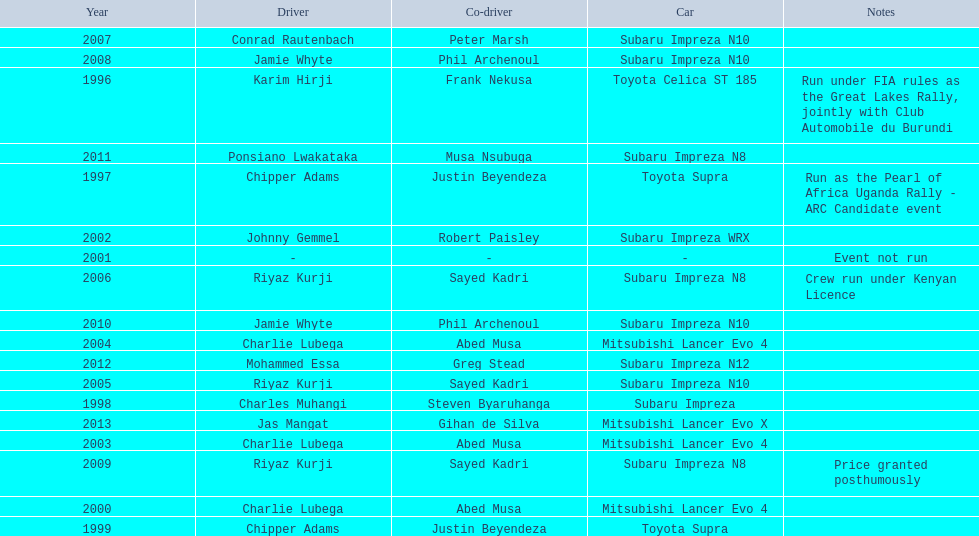Would you mind parsing the complete table? {'header': ['Year', 'Driver', 'Co-driver', 'Car', 'Notes'], 'rows': [['2007', 'Conrad Rautenbach', 'Peter Marsh', 'Subaru Impreza N10', ''], ['2008', 'Jamie Whyte', 'Phil Archenoul', 'Subaru Impreza N10', ''], ['1996', 'Karim Hirji', 'Frank Nekusa', 'Toyota Celica ST 185', 'Run under FIA rules as the Great Lakes Rally, jointly with Club Automobile du Burundi'], ['2011', 'Ponsiano Lwakataka', 'Musa Nsubuga', 'Subaru Impreza N8', ''], ['1997', 'Chipper Adams', 'Justin Beyendeza', 'Toyota Supra', 'Run as the Pearl of Africa Uganda Rally - ARC Candidate event'], ['2002', 'Johnny Gemmel', 'Robert Paisley', 'Subaru Impreza WRX', ''], ['2001', '-', '-', '-', 'Event not run'], ['2006', 'Riyaz Kurji', 'Sayed Kadri', 'Subaru Impreza N8', 'Crew run under Kenyan Licence'], ['2010', 'Jamie Whyte', 'Phil Archenoul', 'Subaru Impreza N10', ''], ['2004', 'Charlie Lubega', 'Abed Musa', 'Mitsubishi Lancer Evo 4', ''], ['2012', 'Mohammed Essa', 'Greg Stead', 'Subaru Impreza N12', ''], ['2005', 'Riyaz Kurji', 'Sayed Kadri', 'Subaru Impreza N10', ''], ['1998', 'Charles Muhangi', 'Steven Byaruhanga', 'Subaru Impreza', ''], ['2013', 'Jas Mangat', 'Gihan de Silva', 'Mitsubishi Lancer Evo X', ''], ['2003', 'Charlie Lubega', 'Abed Musa', 'Mitsubishi Lancer Evo 4', ''], ['2009', 'Riyaz Kurji', 'Sayed Kadri', 'Subaru Impreza N8', 'Price granted posthumously'], ['2000', 'Charlie Lubega', 'Abed Musa', 'Mitsubishi Lancer Evo 4', ''], ['1999', 'Chipper Adams', 'Justin Beyendeza', 'Toyota Supra', '']]} Who is the only driver to have consecutive wins? Charlie Lubega. 